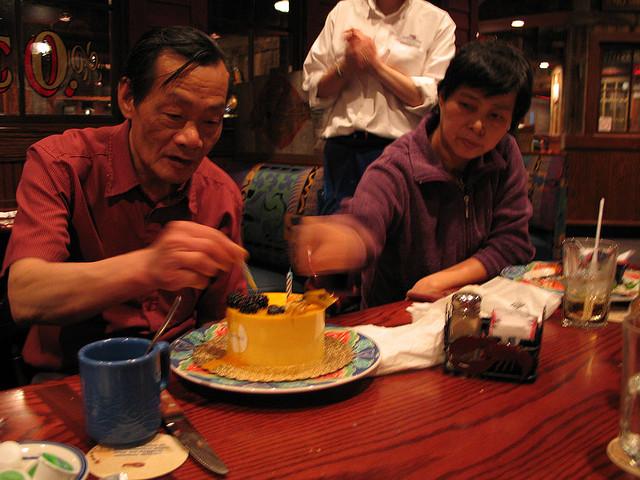How many candles?
Give a very brief answer. 3. What ethnicity are they?
Short answer required. Asian. Is that a birthday cake?
Give a very brief answer. Yes. 